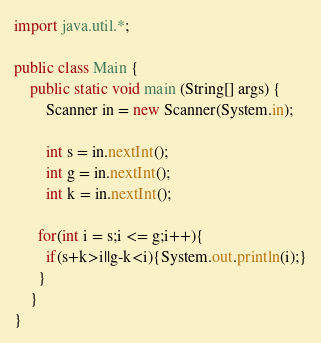<code> <loc_0><loc_0><loc_500><loc_500><_Java_>import java.util.*;
 
public class Main {
	public static void main (String[] args) {
		Scanner in = new Scanner(System.in);
		
		int s = in.nextInt();
      	int g = in.nextInt();
      	int k = in.nextInt();
      
      for(int i = s;i <= g;i++){
        if(s+k>i||g-k<i){System.out.println(i);}
      }
	}
}</code> 